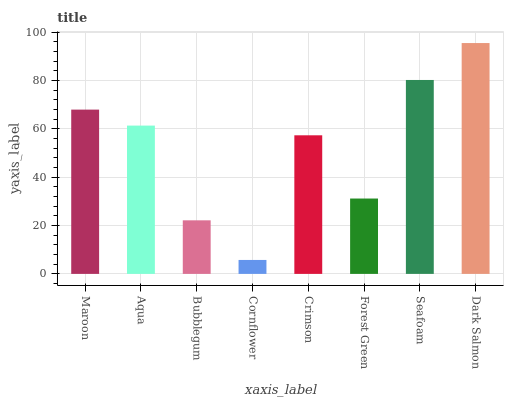Is Cornflower the minimum?
Answer yes or no. Yes. Is Dark Salmon the maximum?
Answer yes or no. Yes. Is Aqua the minimum?
Answer yes or no. No. Is Aqua the maximum?
Answer yes or no. No. Is Maroon greater than Aqua?
Answer yes or no. Yes. Is Aqua less than Maroon?
Answer yes or no. Yes. Is Aqua greater than Maroon?
Answer yes or no. No. Is Maroon less than Aqua?
Answer yes or no. No. Is Aqua the high median?
Answer yes or no. Yes. Is Crimson the low median?
Answer yes or no. Yes. Is Cornflower the high median?
Answer yes or no. No. Is Bubblegum the low median?
Answer yes or no. No. 